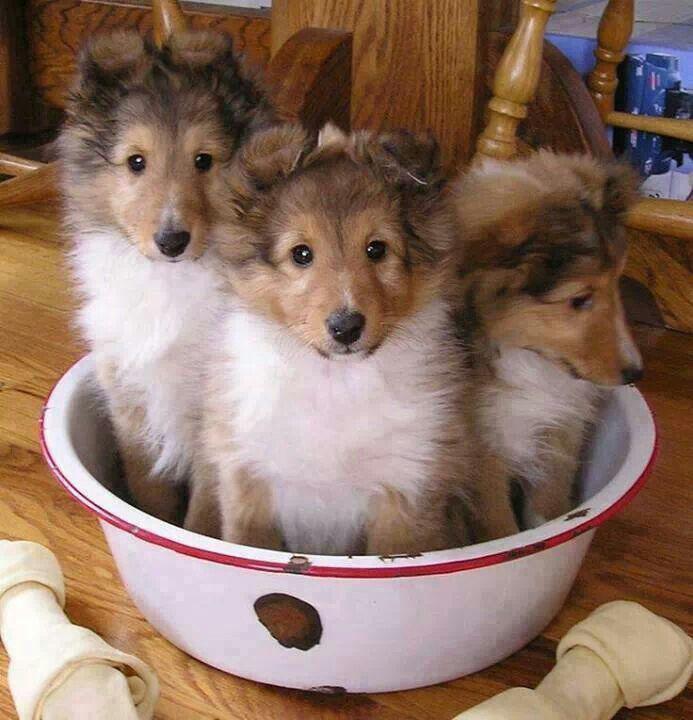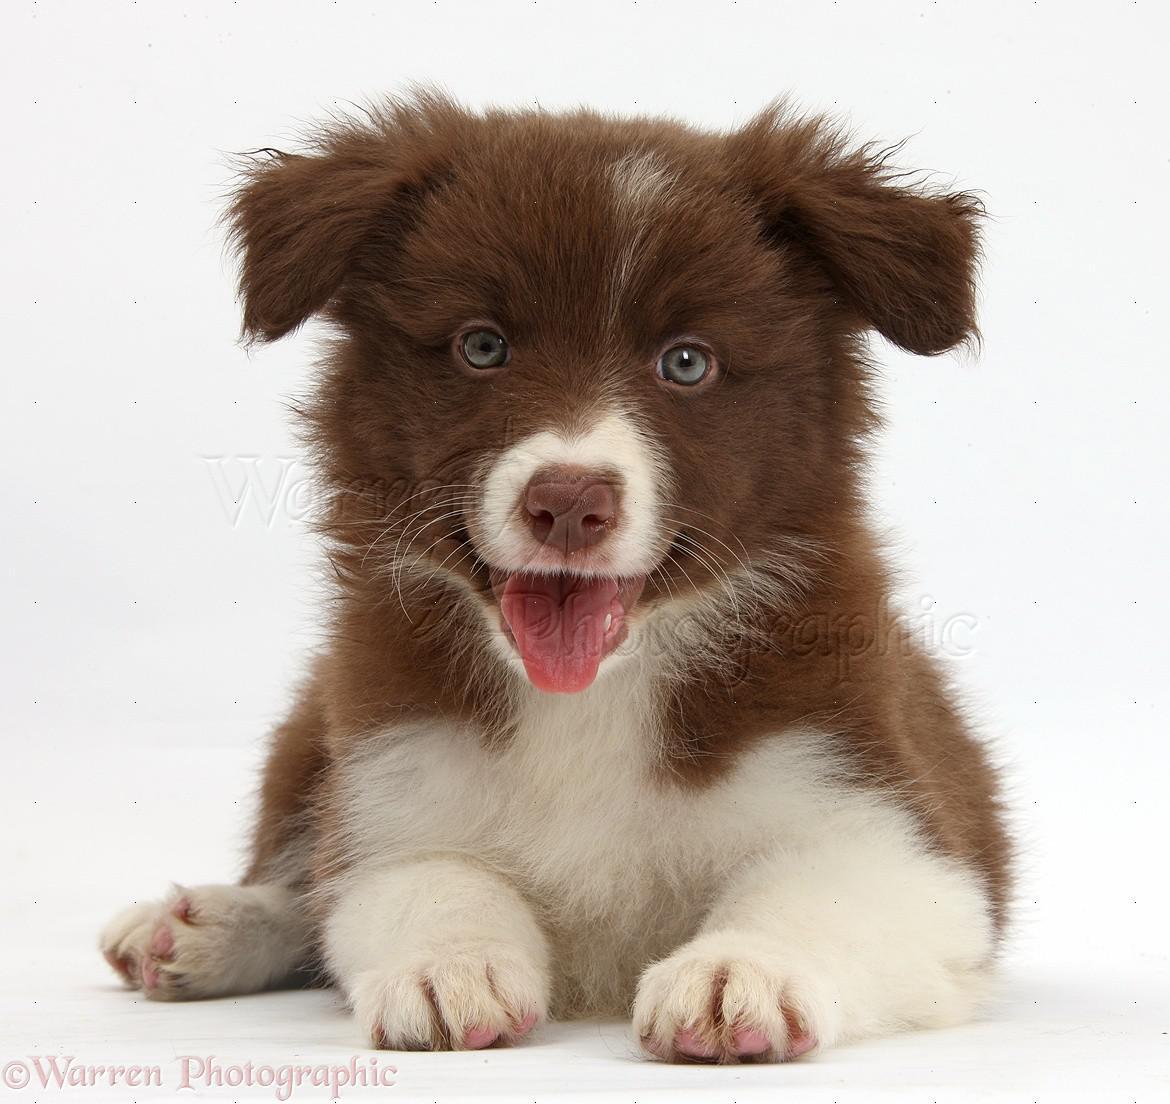The first image is the image on the left, the second image is the image on the right. Examine the images to the left and right. Is the description "there are two dogs in the image pair" accurate? Answer yes or no. No. The first image is the image on the left, the second image is the image on the right. Assess this claim about the two images: "There is dog on top of grass in one of the images.". Correct or not? Answer yes or no. No. 